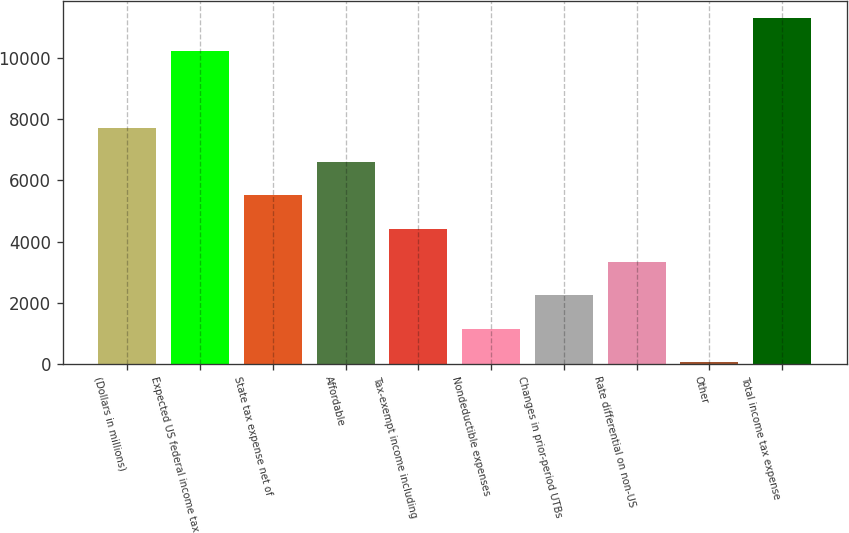Convert chart to OTSL. <chart><loc_0><loc_0><loc_500><loc_500><bar_chart><fcel>(Dollars in millions)<fcel>Expected US federal income tax<fcel>State tax expense net of<fcel>Affordable<fcel>Tax-exempt income including<fcel>Nondeductible expenses<fcel>Changes in prior-period UTBs<fcel>Rate differential on non-US<fcel>Other<fcel>Total income tax expense<nl><fcel>7701.7<fcel>10225<fcel>5515.5<fcel>6608.6<fcel>4422.4<fcel>1143.1<fcel>2236.2<fcel>3329.3<fcel>50<fcel>11318.1<nl></chart> 